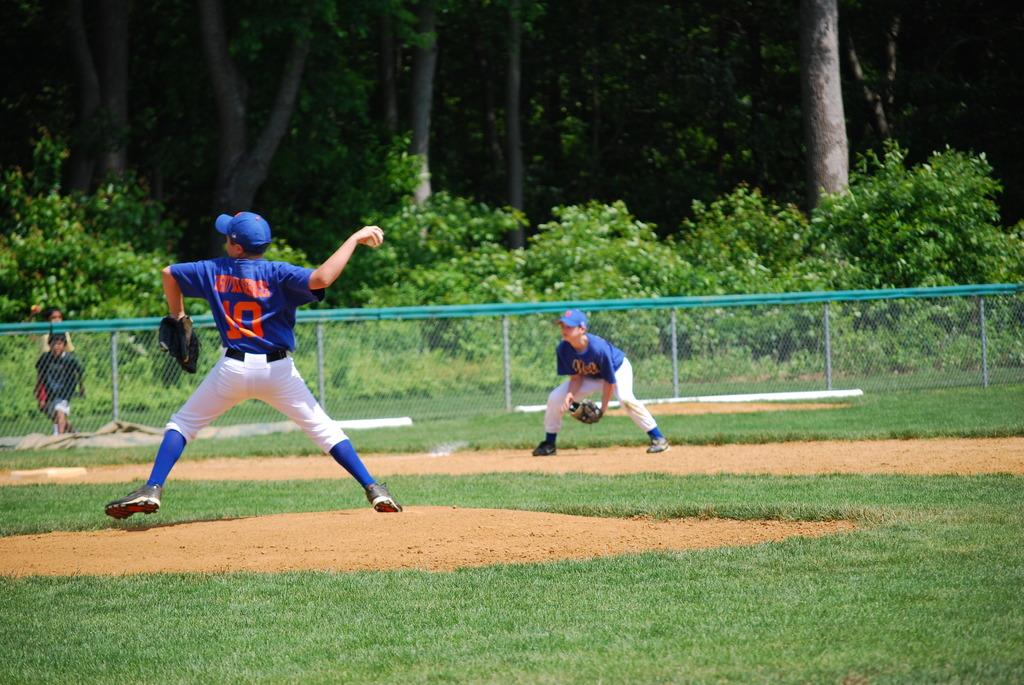<image>
Present a compact description of the photo's key features. number 10 player is on the mound pitching the ball 